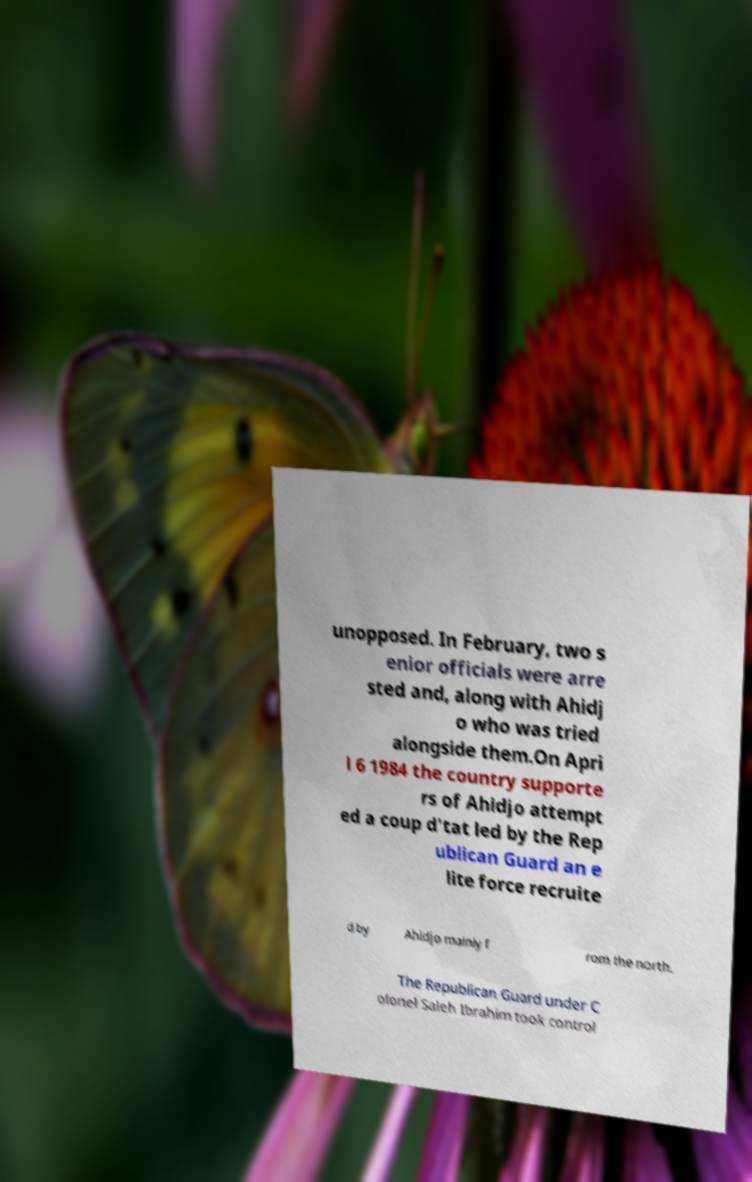For documentation purposes, I need the text within this image transcribed. Could you provide that? unopposed. In February, two s enior officials were arre sted and, along with Ahidj o who was tried alongside them.On Apri l 6 1984 the country supporte rs of Ahidjo attempt ed a coup d'tat led by the Rep ublican Guard an e lite force recruite d by Ahidjo mainly f rom the north. The Republican Guard under C olonel Saleh Ibrahim took control 